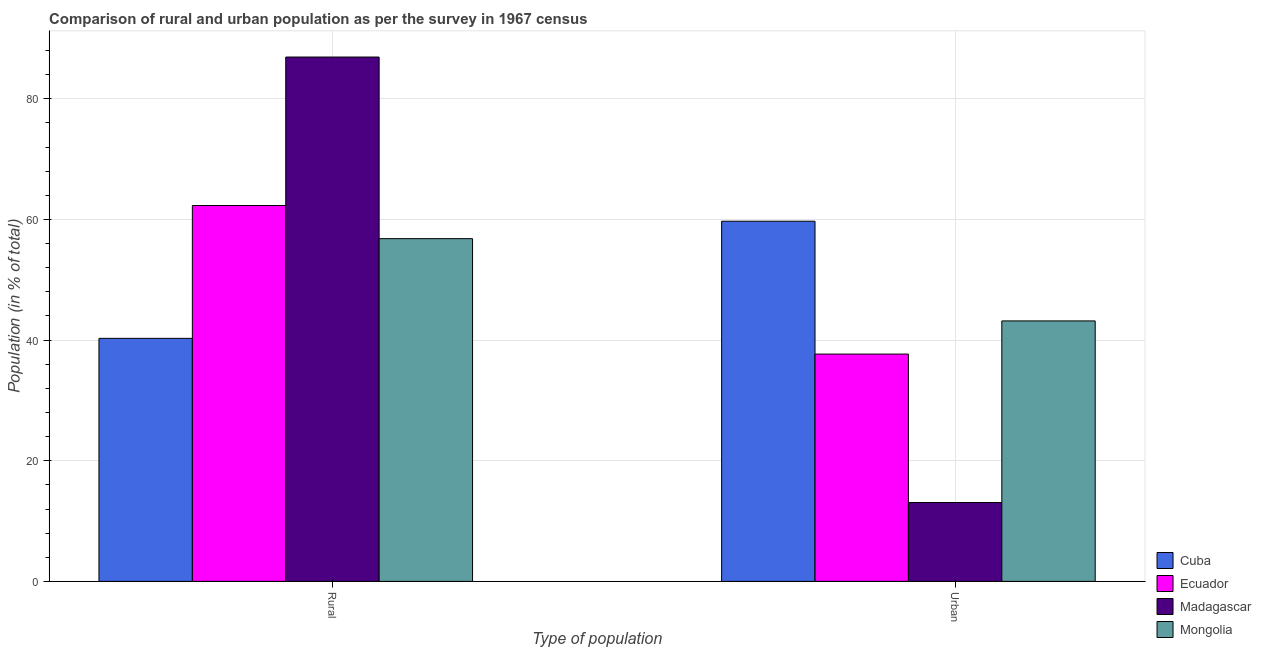How many different coloured bars are there?
Offer a terse response. 4. Are the number of bars on each tick of the X-axis equal?
Your answer should be compact. Yes. How many bars are there on the 1st tick from the left?
Your response must be concise. 4. What is the label of the 2nd group of bars from the left?
Provide a succinct answer. Urban. What is the rural population in Mongolia?
Your response must be concise. 56.82. Across all countries, what is the maximum urban population?
Your response must be concise. 59.71. Across all countries, what is the minimum urban population?
Offer a terse response. 13.07. In which country was the rural population maximum?
Ensure brevity in your answer.  Madagascar. In which country was the urban population minimum?
Provide a succinct answer. Madagascar. What is the total rural population in the graph?
Make the answer very short. 246.35. What is the difference between the urban population in Cuba and that in Ecuador?
Provide a short and direct response. 22.02. What is the difference between the rural population in Cuba and the urban population in Ecuador?
Offer a terse response. 2.6. What is the average rural population per country?
Provide a succinct answer. 61.59. What is the difference between the rural population and urban population in Mongolia?
Your response must be concise. 13.64. What is the ratio of the urban population in Mongolia to that in Cuba?
Make the answer very short. 0.72. What does the 4th bar from the left in Urban represents?
Your answer should be very brief. Mongolia. What does the 2nd bar from the right in Rural represents?
Ensure brevity in your answer.  Madagascar. How many bars are there?
Your response must be concise. 8. Are the values on the major ticks of Y-axis written in scientific E-notation?
Your answer should be compact. No. Does the graph contain any zero values?
Make the answer very short. No. Does the graph contain grids?
Your answer should be compact. Yes. Where does the legend appear in the graph?
Keep it short and to the point. Bottom right. How many legend labels are there?
Your answer should be compact. 4. How are the legend labels stacked?
Keep it short and to the point. Vertical. What is the title of the graph?
Your answer should be compact. Comparison of rural and urban population as per the survey in 1967 census. What is the label or title of the X-axis?
Give a very brief answer. Type of population. What is the label or title of the Y-axis?
Keep it short and to the point. Population (in % of total). What is the Population (in % of total) of Cuba in Rural?
Provide a short and direct response. 40.29. What is the Population (in % of total) of Ecuador in Rural?
Your response must be concise. 62.31. What is the Population (in % of total) in Madagascar in Rural?
Your response must be concise. 86.93. What is the Population (in % of total) of Mongolia in Rural?
Your answer should be compact. 56.82. What is the Population (in % of total) of Cuba in Urban?
Your response must be concise. 59.71. What is the Population (in % of total) in Ecuador in Urban?
Ensure brevity in your answer.  37.69. What is the Population (in % of total) in Madagascar in Urban?
Offer a terse response. 13.07. What is the Population (in % of total) in Mongolia in Urban?
Give a very brief answer. 43.18. Across all Type of population, what is the maximum Population (in % of total) in Cuba?
Ensure brevity in your answer.  59.71. Across all Type of population, what is the maximum Population (in % of total) in Ecuador?
Provide a succinct answer. 62.31. Across all Type of population, what is the maximum Population (in % of total) in Madagascar?
Make the answer very short. 86.93. Across all Type of population, what is the maximum Population (in % of total) of Mongolia?
Make the answer very short. 56.82. Across all Type of population, what is the minimum Population (in % of total) of Cuba?
Ensure brevity in your answer.  40.29. Across all Type of population, what is the minimum Population (in % of total) of Ecuador?
Offer a very short reply. 37.69. Across all Type of population, what is the minimum Population (in % of total) of Madagascar?
Provide a succinct answer. 13.07. Across all Type of population, what is the minimum Population (in % of total) of Mongolia?
Offer a very short reply. 43.18. What is the total Population (in % of total) of Ecuador in the graph?
Offer a very short reply. 100. What is the difference between the Population (in % of total) in Cuba in Rural and that in Urban?
Make the answer very short. -19.42. What is the difference between the Population (in % of total) of Ecuador in Rural and that in Urban?
Give a very brief answer. 24.63. What is the difference between the Population (in % of total) in Madagascar in Rural and that in Urban?
Offer a terse response. 73.85. What is the difference between the Population (in % of total) in Mongolia in Rural and that in Urban?
Provide a short and direct response. 13.64. What is the difference between the Population (in % of total) of Cuba in Rural and the Population (in % of total) of Ecuador in Urban?
Offer a very short reply. 2.6. What is the difference between the Population (in % of total) of Cuba in Rural and the Population (in % of total) of Madagascar in Urban?
Your response must be concise. 27.22. What is the difference between the Population (in % of total) of Cuba in Rural and the Population (in % of total) of Mongolia in Urban?
Give a very brief answer. -2.89. What is the difference between the Population (in % of total) in Ecuador in Rural and the Population (in % of total) in Madagascar in Urban?
Provide a short and direct response. 49.24. What is the difference between the Population (in % of total) of Ecuador in Rural and the Population (in % of total) of Mongolia in Urban?
Make the answer very short. 19.13. What is the difference between the Population (in % of total) in Madagascar in Rural and the Population (in % of total) in Mongolia in Urban?
Ensure brevity in your answer.  43.74. What is the average Population (in % of total) of Cuba per Type of population?
Your answer should be very brief. 50. What is the average Population (in % of total) of Mongolia per Type of population?
Provide a succinct answer. 50. What is the difference between the Population (in % of total) of Cuba and Population (in % of total) of Ecuador in Rural?
Provide a short and direct response. -22.02. What is the difference between the Population (in % of total) in Cuba and Population (in % of total) in Madagascar in Rural?
Offer a very short reply. -46.63. What is the difference between the Population (in % of total) of Cuba and Population (in % of total) of Mongolia in Rural?
Provide a succinct answer. -16.53. What is the difference between the Population (in % of total) in Ecuador and Population (in % of total) in Madagascar in Rural?
Your response must be concise. -24.61. What is the difference between the Population (in % of total) in Ecuador and Population (in % of total) in Mongolia in Rural?
Provide a succinct answer. 5.5. What is the difference between the Population (in % of total) of Madagascar and Population (in % of total) of Mongolia in Rural?
Your answer should be compact. 30.11. What is the difference between the Population (in % of total) of Cuba and Population (in % of total) of Ecuador in Urban?
Your response must be concise. 22.02. What is the difference between the Population (in % of total) of Cuba and Population (in % of total) of Madagascar in Urban?
Ensure brevity in your answer.  46.63. What is the difference between the Population (in % of total) of Cuba and Population (in % of total) of Mongolia in Urban?
Give a very brief answer. 16.53. What is the difference between the Population (in % of total) of Ecuador and Population (in % of total) of Madagascar in Urban?
Offer a very short reply. 24.61. What is the difference between the Population (in % of total) of Ecuador and Population (in % of total) of Mongolia in Urban?
Keep it short and to the point. -5.5. What is the difference between the Population (in % of total) of Madagascar and Population (in % of total) of Mongolia in Urban?
Give a very brief answer. -30.11. What is the ratio of the Population (in % of total) in Cuba in Rural to that in Urban?
Make the answer very short. 0.67. What is the ratio of the Population (in % of total) of Ecuador in Rural to that in Urban?
Ensure brevity in your answer.  1.65. What is the ratio of the Population (in % of total) in Madagascar in Rural to that in Urban?
Your answer should be very brief. 6.65. What is the ratio of the Population (in % of total) in Mongolia in Rural to that in Urban?
Ensure brevity in your answer.  1.32. What is the difference between the highest and the second highest Population (in % of total) of Cuba?
Provide a short and direct response. 19.42. What is the difference between the highest and the second highest Population (in % of total) of Ecuador?
Your answer should be very brief. 24.63. What is the difference between the highest and the second highest Population (in % of total) of Madagascar?
Your response must be concise. 73.85. What is the difference between the highest and the second highest Population (in % of total) of Mongolia?
Your answer should be very brief. 13.64. What is the difference between the highest and the lowest Population (in % of total) in Cuba?
Provide a short and direct response. 19.42. What is the difference between the highest and the lowest Population (in % of total) of Ecuador?
Your answer should be very brief. 24.63. What is the difference between the highest and the lowest Population (in % of total) of Madagascar?
Provide a succinct answer. 73.85. What is the difference between the highest and the lowest Population (in % of total) of Mongolia?
Your answer should be very brief. 13.64. 